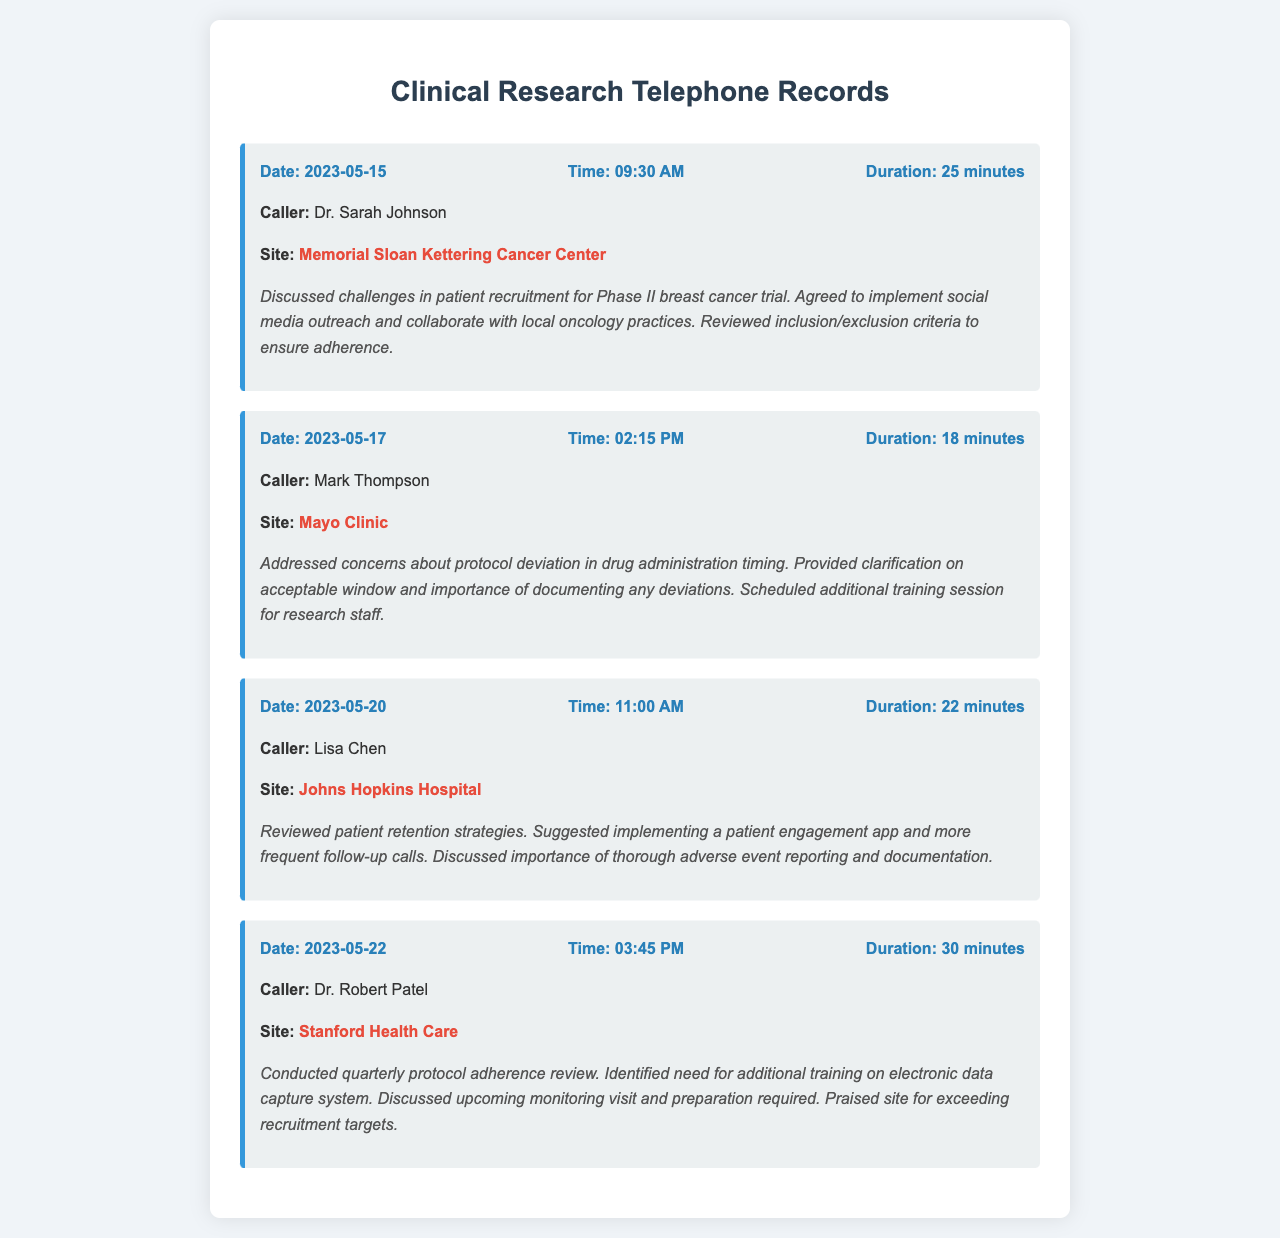what is the date of the call with Dr. Sarah Johnson? The date of the call with Dr. Sarah Johnson is specified in the record as May 15, 2023.
Answer: May 15, 2023 how long was the call with Mark Thompson? The duration of the call with Mark Thompson is mentioned as 18 minutes.
Answer: 18 minutes which site was discussed in the call on May 22, 2023? The site associated with the call on May 22, 2023, is clearly indicated as Stanford Health Care.
Answer: Stanford Health Care what patient recruitment strategy was suggested during the call with Lisa Chen? The recruitment strategy suggested was the implementation of a patient engagement app and more frequent follow-up calls as per the notes from the call.
Answer: patient engagement app who identified the need for additional training on electronic data capture? The need for additional training on electronic data capture was identified by Dr. Robert Patel during the quarterly review.
Answer: Dr. Robert Patel what was the focus of the call on May 20? The main focus of the call on May 20 was patient retention strategies, as outlined in the notes.
Answer: patient retention strategies how many minutes did the call with Dr. Robert Patel last? The call with Dr. Robert Patel lasted for 30 minutes according to the documented record.
Answer: 30 minutes what challenge was discussed in the call with Dr. Sarah Johnson? The challenge discussed was related to patient recruitment for a Phase II breast cancer trial, as stated in the notes.
Answer: patient recruitment 